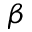Convert formula to latex. <formula><loc_0><loc_0><loc_500><loc_500>\beta</formula> 